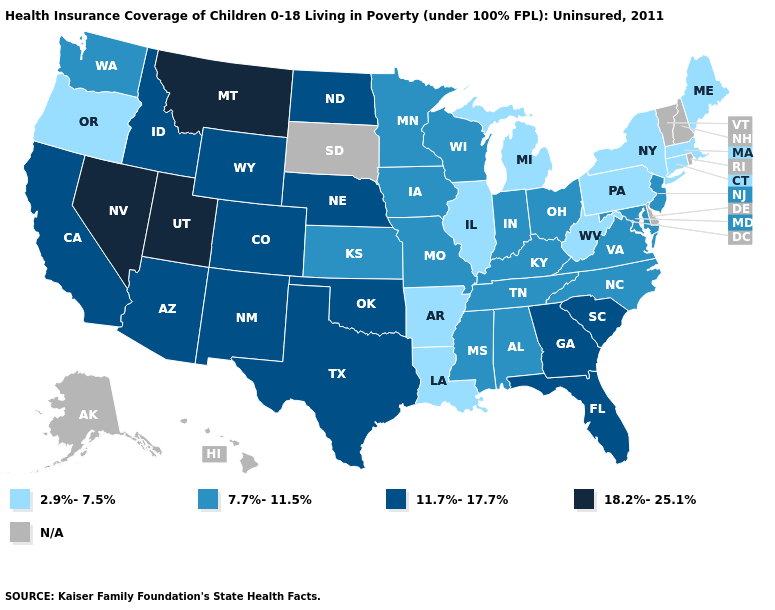How many symbols are there in the legend?
Write a very short answer. 5. Does the first symbol in the legend represent the smallest category?
Short answer required. Yes. Among the states that border Iowa , which have the highest value?
Be succinct. Nebraska. Name the states that have a value in the range 18.2%-25.1%?
Answer briefly. Montana, Nevada, Utah. Does New York have the highest value in the Northeast?
Quick response, please. No. What is the value of Vermont?
Short answer required. N/A. What is the highest value in states that border Wisconsin?
Give a very brief answer. 7.7%-11.5%. Name the states that have a value in the range 18.2%-25.1%?
Keep it brief. Montana, Nevada, Utah. Name the states that have a value in the range 18.2%-25.1%?
Short answer required. Montana, Nevada, Utah. Does Montana have the highest value in the USA?
Be succinct. Yes. What is the value of Utah?
Write a very short answer. 18.2%-25.1%. Does Arkansas have the lowest value in the USA?
Be succinct. Yes. Name the states that have a value in the range 2.9%-7.5%?
Keep it brief. Arkansas, Connecticut, Illinois, Louisiana, Maine, Massachusetts, Michigan, New York, Oregon, Pennsylvania, West Virginia. What is the highest value in the Northeast ?
Be succinct. 7.7%-11.5%. 